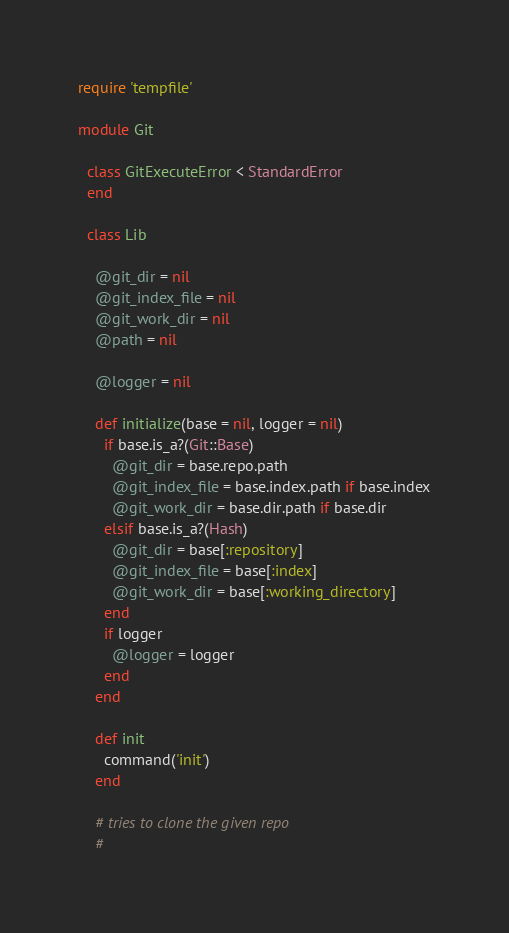Convert code to text. <code><loc_0><loc_0><loc_500><loc_500><_Ruby_>require 'tempfile'

module Git
  
  class GitExecuteError < StandardError 
  end
  
  class Lib
      
    @git_dir = nil
    @git_index_file = nil
    @git_work_dir = nil
    @path = nil
    
    @logger = nil
    
    def initialize(base = nil, logger = nil)
      if base.is_a?(Git::Base)
        @git_dir = base.repo.path
        @git_index_file = base.index.path if base.index
        @git_work_dir = base.dir.path if base.dir
      elsif base.is_a?(Hash)
        @git_dir = base[:repository]
        @git_index_file = base[:index] 
        @git_work_dir = base[:working_directory]
      end
      if logger
        @logger = logger
      end
    end
    
    def init
      command('init')
    end
    
    # tries to clone the given repo
    #</code> 